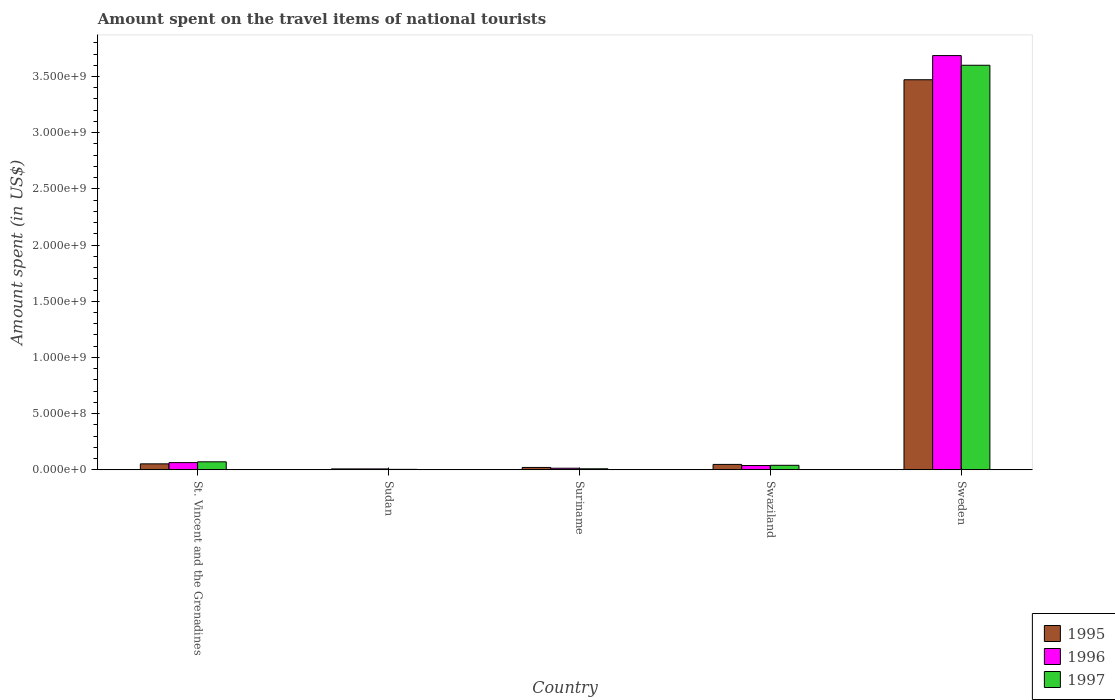Are the number of bars per tick equal to the number of legend labels?
Ensure brevity in your answer.  Yes. How many bars are there on the 3rd tick from the left?
Your answer should be very brief. 3. How many bars are there on the 1st tick from the right?
Give a very brief answer. 3. What is the label of the 3rd group of bars from the left?
Provide a short and direct response. Suriname. What is the amount spent on the travel items of national tourists in 1995 in Sudan?
Your response must be concise. 8.00e+06. Across all countries, what is the maximum amount spent on the travel items of national tourists in 1995?
Offer a very short reply. 3.47e+09. In which country was the amount spent on the travel items of national tourists in 1996 maximum?
Your answer should be very brief. Sweden. In which country was the amount spent on the travel items of national tourists in 1997 minimum?
Provide a short and direct response. Sudan. What is the total amount spent on the travel items of national tourists in 1997 in the graph?
Provide a short and direct response. 3.72e+09. What is the difference between the amount spent on the travel items of national tourists in 1997 in St. Vincent and the Grenadines and that in Suriname?
Your answer should be compact. 6.20e+07. What is the difference between the amount spent on the travel items of national tourists in 1996 in Sweden and the amount spent on the travel items of national tourists in 1997 in Sudan?
Give a very brief answer. 3.68e+09. What is the average amount spent on the travel items of national tourists in 1996 per country?
Your answer should be very brief. 7.62e+08. What is the ratio of the amount spent on the travel items of national tourists in 1997 in St. Vincent and the Grenadines to that in Sweden?
Your response must be concise. 0.02. What is the difference between the highest and the second highest amount spent on the travel items of national tourists in 1996?
Provide a short and direct response. 3.62e+09. What is the difference between the highest and the lowest amount spent on the travel items of national tourists in 1995?
Offer a terse response. 3.46e+09. Is the sum of the amount spent on the travel items of national tourists in 1997 in Swaziland and Sweden greater than the maximum amount spent on the travel items of national tourists in 1995 across all countries?
Provide a short and direct response. Yes. What does the 2nd bar from the left in Suriname represents?
Provide a succinct answer. 1996. What does the 2nd bar from the right in St. Vincent and the Grenadines represents?
Your answer should be very brief. 1996. How many bars are there?
Your response must be concise. 15. How many countries are there in the graph?
Provide a short and direct response. 5. Does the graph contain grids?
Offer a very short reply. No. Where does the legend appear in the graph?
Offer a very short reply. Bottom right. How many legend labels are there?
Provide a short and direct response. 3. How are the legend labels stacked?
Offer a terse response. Vertical. What is the title of the graph?
Give a very brief answer. Amount spent on the travel items of national tourists. Does "2007" appear as one of the legend labels in the graph?
Give a very brief answer. No. What is the label or title of the Y-axis?
Your answer should be compact. Amount spent (in US$). What is the Amount spent (in US$) in 1995 in St. Vincent and the Grenadines?
Provide a short and direct response. 5.30e+07. What is the Amount spent (in US$) in 1996 in St. Vincent and the Grenadines?
Keep it short and to the point. 6.40e+07. What is the Amount spent (in US$) in 1997 in St. Vincent and the Grenadines?
Make the answer very short. 7.10e+07. What is the Amount spent (in US$) of 1995 in Sudan?
Your response must be concise. 8.00e+06. What is the Amount spent (in US$) in 1996 in Sudan?
Keep it short and to the point. 8.00e+06. What is the Amount spent (in US$) in 1995 in Suriname?
Keep it short and to the point. 2.10e+07. What is the Amount spent (in US$) of 1996 in Suriname?
Your answer should be compact. 1.40e+07. What is the Amount spent (in US$) of 1997 in Suriname?
Your answer should be compact. 9.00e+06. What is the Amount spent (in US$) of 1995 in Swaziland?
Provide a succinct answer. 4.80e+07. What is the Amount spent (in US$) in 1996 in Swaziland?
Offer a terse response. 3.80e+07. What is the Amount spent (in US$) in 1997 in Swaziland?
Provide a succinct answer. 4.00e+07. What is the Amount spent (in US$) of 1995 in Sweden?
Ensure brevity in your answer.  3.47e+09. What is the Amount spent (in US$) of 1996 in Sweden?
Ensure brevity in your answer.  3.69e+09. What is the Amount spent (in US$) in 1997 in Sweden?
Ensure brevity in your answer.  3.60e+09. Across all countries, what is the maximum Amount spent (in US$) in 1995?
Your answer should be compact. 3.47e+09. Across all countries, what is the maximum Amount spent (in US$) in 1996?
Your answer should be very brief. 3.69e+09. Across all countries, what is the maximum Amount spent (in US$) in 1997?
Offer a very short reply. 3.60e+09. Across all countries, what is the minimum Amount spent (in US$) of 1995?
Provide a succinct answer. 8.00e+06. Across all countries, what is the minimum Amount spent (in US$) in 1996?
Your answer should be very brief. 8.00e+06. Across all countries, what is the minimum Amount spent (in US$) in 1997?
Your answer should be compact. 4.00e+06. What is the total Amount spent (in US$) in 1995 in the graph?
Keep it short and to the point. 3.60e+09. What is the total Amount spent (in US$) in 1996 in the graph?
Your response must be concise. 3.81e+09. What is the total Amount spent (in US$) in 1997 in the graph?
Offer a very short reply. 3.72e+09. What is the difference between the Amount spent (in US$) in 1995 in St. Vincent and the Grenadines and that in Sudan?
Offer a terse response. 4.50e+07. What is the difference between the Amount spent (in US$) in 1996 in St. Vincent and the Grenadines and that in Sudan?
Make the answer very short. 5.60e+07. What is the difference between the Amount spent (in US$) in 1997 in St. Vincent and the Grenadines and that in Sudan?
Your answer should be very brief. 6.70e+07. What is the difference between the Amount spent (in US$) of 1995 in St. Vincent and the Grenadines and that in Suriname?
Offer a very short reply. 3.20e+07. What is the difference between the Amount spent (in US$) of 1996 in St. Vincent and the Grenadines and that in Suriname?
Your answer should be compact. 5.00e+07. What is the difference between the Amount spent (in US$) of 1997 in St. Vincent and the Grenadines and that in Suriname?
Offer a terse response. 6.20e+07. What is the difference between the Amount spent (in US$) in 1996 in St. Vincent and the Grenadines and that in Swaziland?
Your answer should be compact. 2.60e+07. What is the difference between the Amount spent (in US$) in 1997 in St. Vincent and the Grenadines and that in Swaziland?
Keep it short and to the point. 3.10e+07. What is the difference between the Amount spent (in US$) of 1995 in St. Vincent and the Grenadines and that in Sweden?
Provide a succinct answer. -3.42e+09. What is the difference between the Amount spent (in US$) of 1996 in St. Vincent and the Grenadines and that in Sweden?
Make the answer very short. -3.62e+09. What is the difference between the Amount spent (in US$) of 1997 in St. Vincent and the Grenadines and that in Sweden?
Offer a very short reply. -3.53e+09. What is the difference between the Amount spent (in US$) of 1995 in Sudan and that in Suriname?
Your answer should be very brief. -1.30e+07. What is the difference between the Amount spent (in US$) in 1996 in Sudan and that in Suriname?
Offer a very short reply. -6.00e+06. What is the difference between the Amount spent (in US$) of 1997 in Sudan and that in Suriname?
Keep it short and to the point. -5.00e+06. What is the difference between the Amount spent (in US$) in 1995 in Sudan and that in Swaziland?
Make the answer very short. -4.00e+07. What is the difference between the Amount spent (in US$) of 1996 in Sudan and that in Swaziland?
Give a very brief answer. -3.00e+07. What is the difference between the Amount spent (in US$) in 1997 in Sudan and that in Swaziland?
Ensure brevity in your answer.  -3.60e+07. What is the difference between the Amount spent (in US$) in 1995 in Sudan and that in Sweden?
Keep it short and to the point. -3.46e+09. What is the difference between the Amount spent (in US$) of 1996 in Sudan and that in Sweden?
Your response must be concise. -3.68e+09. What is the difference between the Amount spent (in US$) in 1997 in Sudan and that in Sweden?
Provide a short and direct response. -3.60e+09. What is the difference between the Amount spent (in US$) of 1995 in Suriname and that in Swaziland?
Provide a succinct answer. -2.70e+07. What is the difference between the Amount spent (in US$) in 1996 in Suriname and that in Swaziland?
Ensure brevity in your answer.  -2.40e+07. What is the difference between the Amount spent (in US$) in 1997 in Suriname and that in Swaziland?
Keep it short and to the point. -3.10e+07. What is the difference between the Amount spent (in US$) of 1995 in Suriname and that in Sweden?
Offer a very short reply. -3.45e+09. What is the difference between the Amount spent (in US$) in 1996 in Suriname and that in Sweden?
Offer a terse response. -3.67e+09. What is the difference between the Amount spent (in US$) in 1997 in Suriname and that in Sweden?
Your response must be concise. -3.59e+09. What is the difference between the Amount spent (in US$) in 1995 in Swaziland and that in Sweden?
Ensure brevity in your answer.  -3.42e+09. What is the difference between the Amount spent (in US$) in 1996 in Swaziland and that in Sweden?
Make the answer very short. -3.65e+09. What is the difference between the Amount spent (in US$) of 1997 in Swaziland and that in Sweden?
Offer a terse response. -3.56e+09. What is the difference between the Amount spent (in US$) in 1995 in St. Vincent and the Grenadines and the Amount spent (in US$) in 1996 in Sudan?
Offer a very short reply. 4.50e+07. What is the difference between the Amount spent (in US$) of 1995 in St. Vincent and the Grenadines and the Amount spent (in US$) of 1997 in Sudan?
Your answer should be compact. 4.90e+07. What is the difference between the Amount spent (in US$) of 1996 in St. Vincent and the Grenadines and the Amount spent (in US$) of 1997 in Sudan?
Offer a terse response. 6.00e+07. What is the difference between the Amount spent (in US$) in 1995 in St. Vincent and the Grenadines and the Amount spent (in US$) in 1996 in Suriname?
Your answer should be compact. 3.90e+07. What is the difference between the Amount spent (in US$) in 1995 in St. Vincent and the Grenadines and the Amount spent (in US$) in 1997 in Suriname?
Your answer should be very brief. 4.40e+07. What is the difference between the Amount spent (in US$) of 1996 in St. Vincent and the Grenadines and the Amount spent (in US$) of 1997 in Suriname?
Your response must be concise. 5.50e+07. What is the difference between the Amount spent (in US$) of 1995 in St. Vincent and the Grenadines and the Amount spent (in US$) of 1996 in Swaziland?
Make the answer very short. 1.50e+07. What is the difference between the Amount spent (in US$) of 1995 in St. Vincent and the Grenadines and the Amount spent (in US$) of 1997 in Swaziland?
Make the answer very short. 1.30e+07. What is the difference between the Amount spent (in US$) of 1996 in St. Vincent and the Grenadines and the Amount spent (in US$) of 1997 in Swaziland?
Provide a succinct answer. 2.40e+07. What is the difference between the Amount spent (in US$) of 1995 in St. Vincent and the Grenadines and the Amount spent (in US$) of 1996 in Sweden?
Your response must be concise. -3.63e+09. What is the difference between the Amount spent (in US$) of 1995 in St. Vincent and the Grenadines and the Amount spent (in US$) of 1997 in Sweden?
Give a very brief answer. -3.55e+09. What is the difference between the Amount spent (in US$) in 1996 in St. Vincent and the Grenadines and the Amount spent (in US$) in 1997 in Sweden?
Provide a short and direct response. -3.54e+09. What is the difference between the Amount spent (in US$) in 1995 in Sudan and the Amount spent (in US$) in 1996 in Suriname?
Make the answer very short. -6.00e+06. What is the difference between the Amount spent (in US$) in 1995 in Sudan and the Amount spent (in US$) in 1997 in Suriname?
Make the answer very short. -1.00e+06. What is the difference between the Amount spent (in US$) of 1995 in Sudan and the Amount spent (in US$) of 1996 in Swaziland?
Provide a succinct answer. -3.00e+07. What is the difference between the Amount spent (in US$) of 1995 in Sudan and the Amount spent (in US$) of 1997 in Swaziland?
Keep it short and to the point. -3.20e+07. What is the difference between the Amount spent (in US$) in 1996 in Sudan and the Amount spent (in US$) in 1997 in Swaziland?
Keep it short and to the point. -3.20e+07. What is the difference between the Amount spent (in US$) in 1995 in Sudan and the Amount spent (in US$) in 1996 in Sweden?
Keep it short and to the point. -3.68e+09. What is the difference between the Amount spent (in US$) of 1995 in Sudan and the Amount spent (in US$) of 1997 in Sweden?
Your response must be concise. -3.59e+09. What is the difference between the Amount spent (in US$) in 1996 in Sudan and the Amount spent (in US$) in 1997 in Sweden?
Your answer should be very brief. -3.59e+09. What is the difference between the Amount spent (in US$) of 1995 in Suriname and the Amount spent (in US$) of 1996 in Swaziland?
Offer a very short reply. -1.70e+07. What is the difference between the Amount spent (in US$) of 1995 in Suriname and the Amount spent (in US$) of 1997 in Swaziland?
Offer a very short reply. -1.90e+07. What is the difference between the Amount spent (in US$) in 1996 in Suriname and the Amount spent (in US$) in 1997 in Swaziland?
Give a very brief answer. -2.60e+07. What is the difference between the Amount spent (in US$) of 1995 in Suriname and the Amount spent (in US$) of 1996 in Sweden?
Ensure brevity in your answer.  -3.66e+09. What is the difference between the Amount spent (in US$) in 1995 in Suriname and the Amount spent (in US$) in 1997 in Sweden?
Offer a terse response. -3.58e+09. What is the difference between the Amount spent (in US$) in 1996 in Suriname and the Amount spent (in US$) in 1997 in Sweden?
Ensure brevity in your answer.  -3.59e+09. What is the difference between the Amount spent (in US$) in 1995 in Swaziland and the Amount spent (in US$) in 1996 in Sweden?
Offer a very short reply. -3.64e+09. What is the difference between the Amount spent (in US$) of 1995 in Swaziland and the Amount spent (in US$) of 1997 in Sweden?
Your answer should be compact. -3.55e+09. What is the difference between the Amount spent (in US$) of 1996 in Swaziland and the Amount spent (in US$) of 1997 in Sweden?
Your answer should be very brief. -3.56e+09. What is the average Amount spent (in US$) of 1995 per country?
Offer a very short reply. 7.20e+08. What is the average Amount spent (in US$) of 1996 per country?
Your response must be concise. 7.62e+08. What is the average Amount spent (in US$) of 1997 per country?
Provide a succinct answer. 7.45e+08. What is the difference between the Amount spent (in US$) of 1995 and Amount spent (in US$) of 1996 in St. Vincent and the Grenadines?
Ensure brevity in your answer.  -1.10e+07. What is the difference between the Amount spent (in US$) in 1995 and Amount spent (in US$) in 1997 in St. Vincent and the Grenadines?
Your answer should be compact. -1.80e+07. What is the difference between the Amount spent (in US$) of 1996 and Amount spent (in US$) of 1997 in St. Vincent and the Grenadines?
Offer a very short reply. -7.00e+06. What is the difference between the Amount spent (in US$) of 1995 and Amount spent (in US$) of 1996 in Sudan?
Give a very brief answer. 0. What is the difference between the Amount spent (in US$) of 1996 and Amount spent (in US$) of 1997 in Sudan?
Your response must be concise. 4.00e+06. What is the difference between the Amount spent (in US$) in 1995 and Amount spent (in US$) in 1997 in Suriname?
Give a very brief answer. 1.20e+07. What is the difference between the Amount spent (in US$) in 1996 and Amount spent (in US$) in 1997 in Suriname?
Your answer should be compact. 5.00e+06. What is the difference between the Amount spent (in US$) of 1995 and Amount spent (in US$) of 1996 in Sweden?
Provide a succinct answer. -2.15e+08. What is the difference between the Amount spent (in US$) in 1995 and Amount spent (in US$) in 1997 in Sweden?
Ensure brevity in your answer.  -1.29e+08. What is the difference between the Amount spent (in US$) of 1996 and Amount spent (in US$) of 1997 in Sweden?
Make the answer very short. 8.60e+07. What is the ratio of the Amount spent (in US$) of 1995 in St. Vincent and the Grenadines to that in Sudan?
Your response must be concise. 6.62. What is the ratio of the Amount spent (in US$) of 1996 in St. Vincent and the Grenadines to that in Sudan?
Make the answer very short. 8. What is the ratio of the Amount spent (in US$) of 1997 in St. Vincent and the Grenadines to that in Sudan?
Your response must be concise. 17.75. What is the ratio of the Amount spent (in US$) in 1995 in St. Vincent and the Grenadines to that in Suriname?
Give a very brief answer. 2.52. What is the ratio of the Amount spent (in US$) in 1996 in St. Vincent and the Grenadines to that in Suriname?
Offer a very short reply. 4.57. What is the ratio of the Amount spent (in US$) in 1997 in St. Vincent and the Grenadines to that in Suriname?
Offer a terse response. 7.89. What is the ratio of the Amount spent (in US$) in 1995 in St. Vincent and the Grenadines to that in Swaziland?
Your answer should be very brief. 1.1. What is the ratio of the Amount spent (in US$) in 1996 in St. Vincent and the Grenadines to that in Swaziland?
Provide a short and direct response. 1.68. What is the ratio of the Amount spent (in US$) in 1997 in St. Vincent and the Grenadines to that in Swaziland?
Your answer should be very brief. 1.77. What is the ratio of the Amount spent (in US$) of 1995 in St. Vincent and the Grenadines to that in Sweden?
Keep it short and to the point. 0.02. What is the ratio of the Amount spent (in US$) in 1996 in St. Vincent and the Grenadines to that in Sweden?
Ensure brevity in your answer.  0.02. What is the ratio of the Amount spent (in US$) of 1997 in St. Vincent and the Grenadines to that in Sweden?
Keep it short and to the point. 0.02. What is the ratio of the Amount spent (in US$) of 1995 in Sudan to that in Suriname?
Provide a short and direct response. 0.38. What is the ratio of the Amount spent (in US$) of 1996 in Sudan to that in Suriname?
Your answer should be very brief. 0.57. What is the ratio of the Amount spent (in US$) of 1997 in Sudan to that in Suriname?
Your answer should be very brief. 0.44. What is the ratio of the Amount spent (in US$) of 1995 in Sudan to that in Swaziland?
Ensure brevity in your answer.  0.17. What is the ratio of the Amount spent (in US$) in 1996 in Sudan to that in Swaziland?
Provide a short and direct response. 0.21. What is the ratio of the Amount spent (in US$) of 1995 in Sudan to that in Sweden?
Provide a short and direct response. 0. What is the ratio of the Amount spent (in US$) in 1996 in Sudan to that in Sweden?
Your answer should be very brief. 0. What is the ratio of the Amount spent (in US$) in 1997 in Sudan to that in Sweden?
Your answer should be compact. 0. What is the ratio of the Amount spent (in US$) of 1995 in Suriname to that in Swaziland?
Your response must be concise. 0.44. What is the ratio of the Amount spent (in US$) in 1996 in Suriname to that in Swaziland?
Your response must be concise. 0.37. What is the ratio of the Amount spent (in US$) of 1997 in Suriname to that in Swaziland?
Give a very brief answer. 0.23. What is the ratio of the Amount spent (in US$) of 1995 in Suriname to that in Sweden?
Keep it short and to the point. 0.01. What is the ratio of the Amount spent (in US$) of 1996 in Suriname to that in Sweden?
Offer a terse response. 0. What is the ratio of the Amount spent (in US$) of 1997 in Suriname to that in Sweden?
Your response must be concise. 0. What is the ratio of the Amount spent (in US$) in 1995 in Swaziland to that in Sweden?
Your response must be concise. 0.01. What is the ratio of the Amount spent (in US$) in 1996 in Swaziland to that in Sweden?
Offer a terse response. 0.01. What is the ratio of the Amount spent (in US$) in 1997 in Swaziland to that in Sweden?
Offer a very short reply. 0.01. What is the difference between the highest and the second highest Amount spent (in US$) of 1995?
Your answer should be very brief. 3.42e+09. What is the difference between the highest and the second highest Amount spent (in US$) of 1996?
Provide a succinct answer. 3.62e+09. What is the difference between the highest and the second highest Amount spent (in US$) in 1997?
Offer a very short reply. 3.53e+09. What is the difference between the highest and the lowest Amount spent (in US$) in 1995?
Keep it short and to the point. 3.46e+09. What is the difference between the highest and the lowest Amount spent (in US$) in 1996?
Give a very brief answer. 3.68e+09. What is the difference between the highest and the lowest Amount spent (in US$) of 1997?
Provide a succinct answer. 3.60e+09. 